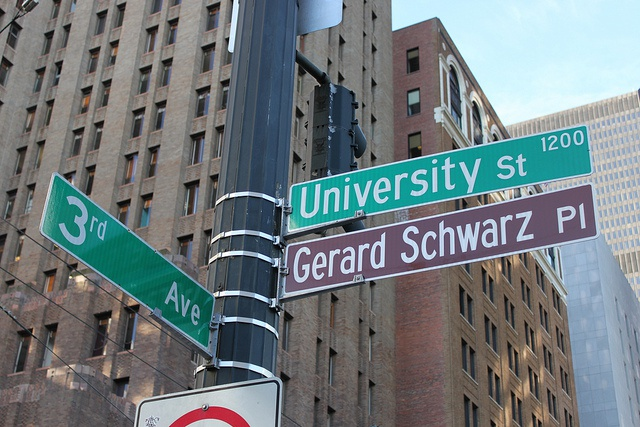Describe the objects in this image and their specific colors. I can see a traffic light in gray, black, and darkblue tones in this image. 